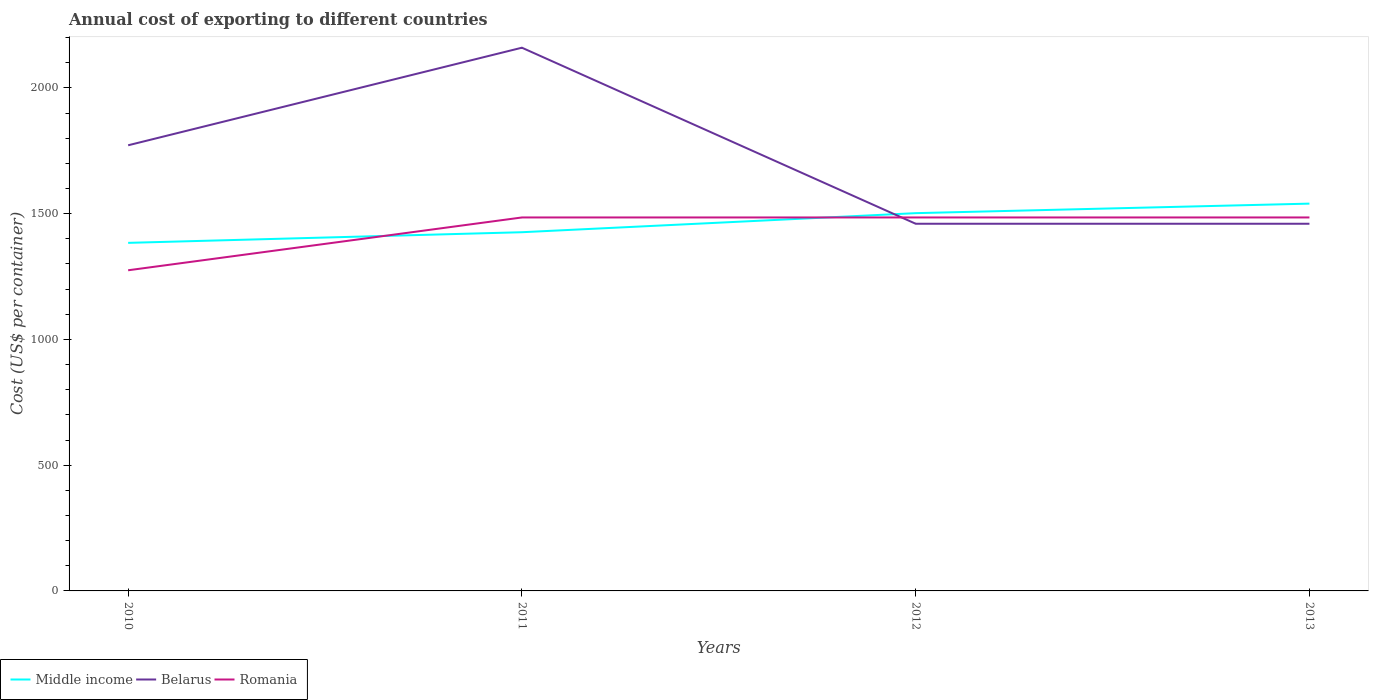Across all years, what is the maximum total annual cost of exporting in Middle income?
Provide a short and direct response. 1383.99. In which year was the total annual cost of exporting in Middle income maximum?
Provide a succinct answer. 2010. What is the total total annual cost of exporting in Middle income in the graph?
Offer a very short reply. -118.11. What is the difference between the highest and the second highest total annual cost of exporting in Middle income?
Your answer should be compact. 156.01. Is the total annual cost of exporting in Romania strictly greater than the total annual cost of exporting in Belarus over the years?
Keep it short and to the point. No. How many years are there in the graph?
Your response must be concise. 4. Where does the legend appear in the graph?
Your answer should be compact. Bottom left. How are the legend labels stacked?
Make the answer very short. Horizontal. What is the title of the graph?
Make the answer very short. Annual cost of exporting to different countries. Does "OECD members" appear as one of the legend labels in the graph?
Provide a succinct answer. No. What is the label or title of the X-axis?
Your answer should be very brief. Years. What is the label or title of the Y-axis?
Your answer should be compact. Cost (US$ per container). What is the Cost (US$ per container) of Middle income in 2010?
Keep it short and to the point. 1383.99. What is the Cost (US$ per container) in Belarus in 2010?
Your response must be concise. 1772. What is the Cost (US$ per container) in Romania in 2010?
Provide a short and direct response. 1275. What is the Cost (US$ per container) of Middle income in 2011?
Ensure brevity in your answer.  1426.34. What is the Cost (US$ per container) of Belarus in 2011?
Your answer should be compact. 2160. What is the Cost (US$ per container) in Romania in 2011?
Ensure brevity in your answer.  1485. What is the Cost (US$ per container) of Middle income in 2012?
Your response must be concise. 1502.1. What is the Cost (US$ per container) in Belarus in 2012?
Keep it short and to the point. 1460. What is the Cost (US$ per container) in Romania in 2012?
Give a very brief answer. 1485. What is the Cost (US$ per container) of Middle income in 2013?
Offer a terse response. 1540. What is the Cost (US$ per container) of Belarus in 2013?
Provide a short and direct response. 1460. What is the Cost (US$ per container) of Romania in 2013?
Provide a short and direct response. 1485. Across all years, what is the maximum Cost (US$ per container) of Middle income?
Your response must be concise. 1540. Across all years, what is the maximum Cost (US$ per container) of Belarus?
Make the answer very short. 2160. Across all years, what is the maximum Cost (US$ per container) in Romania?
Give a very brief answer. 1485. Across all years, what is the minimum Cost (US$ per container) of Middle income?
Provide a short and direct response. 1383.99. Across all years, what is the minimum Cost (US$ per container) of Belarus?
Your answer should be compact. 1460. Across all years, what is the minimum Cost (US$ per container) in Romania?
Provide a short and direct response. 1275. What is the total Cost (US$ per container) of Middle income in the graph?
Provide a succinct answer. 5852.42. What is the total Cost (US$ per container) in Belarus in the graph?
Make the answer very short. 6852. What is the total Cost (US$ per container) in Romania in the graph?
Give a very brief answer. 5730. What is the difference between the Cost (US$ per container) of Middle income in 2010 and that in 2011?
Your answer should be compact. -42.35. What is the difference between the Cost (US$ per container) in Belarus in 2010 and that in 2011?
Your answer should be very brief. -388. What is the difference between the Cost (US$ per container) of Romania in 2010 and that in 2011?
Provide a succinct answer. -210. What is the difference between the Cost (US$ per container) in Middle income in 2010 and that in 2012?
Provide a succinct answer. -118.11. What is the difference between the Cost (US$ per container) of Belarus in 2010 and that in 2012?
Keep it short and to the point. 312. What is the difference between the Cost (US$ per container) in Romania in 2010 and that in 2012?
Your answer should be very brief. -210. What is the difference between the Cost (US$ per container) of Middle income in 2010 and that in 2013?
Give a very brief answer. -156.01. What is the difference between the Cost (US$ per container) in Belarus in 2010 and that in 2013?
Your answer should be very brief. 312. What is the difference between the Cost (US$ per container) of Romania in 2010 and that in 2013?
Offer a very short reply. -210. What is the difference between the Cost (US$ per container) of Middle income in 2011 and that in 2012?
Offer a terse response. -75.76. What is the difference between the Cost (US$ per container) of Belarus in 2011 and that in 2012?
Give a very brief answer. 700. What is the difference between the Cost (US$ per container) of Romania in 2011 and that in 2012?
Give a very brief answer. 0. What is the difference between the Cost (US$ per container) in Middle income in 2011 and that in 2013?
Your response must be concise. -113.66. What is the difference between the Cost (US$ per container) of Belarus in 2011 and that in 2013?
Make the answer very short. 700. What is the difference between the Cost (US$ per container) in Romania in 2011 and that in 2013?
Your answer should be compact. 0. What is the difference between the Cost (US$ per container) in Middle income in 2012 and that in 2013?
Keep it short and to the point. -37.9. What is the difference between the Cost (US$ per container) of Romania in 2012 and that in 2013?
Your answer should be very brief. 0. What is the difference between the Cost (US$ per container) of Middle income in 2010 and the Cost (US$ per container) of Belarus in 2011?
Give a very brief answer. -776.01. What is the difference between the Cost (US$ per container) of Middle income in 2010 and the Cost (US$ per container) of Romania in 2011?
Your answer should be very brief. -101.01. What is the difference between the Cost (US$ per container) in Belarus in 2010 and the Cost (US$ per container) in Romania in 2011?
Provide a short and direct response. 287. What is the difference between the Cost (US$ per container) of Middle income in 2010 and the Cost (US$ per container) of Belarus in 2012?
Provide a succinct answer. -76.01. What is the difference between the Cost (US$ per container) in Middle income in 2010 and the Cost (US$ per container) in Romania in 2012?
Your response must be concise. -101.01. What is the difference between the Cost (US$ per container) in Belarus in 2010 and the Cost (US$ per container) in Romania in 2012?
Provide a succinct answer. 287. What is the difference between the Cost (US$ per container) of Middle income in 2010 and the Cost (US$ per container) of Belarus in 2013?
Provide a short and direct response. -76.01. What is the difference between the Cost (US$ per container) of Middle income in 2010 and the Cost (US$ per container) of Romania in 2013?
Give a very brief answer. -101.01. What is the difference between the Cost (US$ per container) of Belarus in 2010 and the Cost (US$ per container) of Romania in 2013?
Your answer should be very brief. 287. What is the difference between the Cost (US$ per container) of Middle income in 2011 and the Cost (US$ per container) of Belarus in 2012?
Your answer should be very brief. -33.66. What is the difference between the Cost (US$ per container) in Middle income in 2011 and the Cost (US$ per container) in Romania in 2012?
Offer a terse response. -58.66. What is the difference between the Cost (US$ per container) in Belarus in 2011 and the Cost (US$ per container) in Romania in 2012?
Your answer should be compact. 675. What is the difference between the Cost (US$ per container) in Middle income in 2011 and the Cost (US$ per container) in Belarus in 2013?
Your answer should be compact. -33.66. What is the difference between the Cost (US$ per container) in Middle income in 2011 and the Cost (US$ per container) in Romania in 2013?
Keep it short and to the point. -58.66. What is the difference between the Cost (US$ per container) of Belarus in 2011 and the Cost (US$ per container) of Romania in 2013?
Your answer should be very brief. 675. What is the difference between the Cost (US$ per container) in Middle income in 2012 and the Cost (US$ per container) in Belarus in 2013?
Provide a short and direct response. 42.1. What is the difference between the Cost (US$ per container) of Belarus in 2012 and the Cost (US$ per container) of Romania in 2013?
Ensure brevity in your answer.  -25. What is the average Cost (US$ per container) in Middle income per year?
Provide a short and direct response. 1463.11. What is the average Cost (US$ per container) of Belarus per year?
Give a very brief answer. 1713. What is the average Cost (US$ per container) in Romania per year?
Keep it short and to the point. 1432.5. In the year 2010, what is the difference between the Cost (US$ per container) in Middle income and Cost (US$ per container) in Belarus?
Provide a succinct answer. -388.01. In the year 2010, what is the difference between the Cost (US$ per container) in Middle income and Cost (US$ per container) in Romania?
Your answer should be very brief. 108.99. In the year 2010, what is the difference between the Cost (US$ per container) in Belarus and Cost (US$ per container) in Romania?
Keep it short and to the point. 497. In the year 2011, what is the difference between the Cost (US$ per container) of Middle income and Cost (US$ per container) of Belarus?
Your response must be concise. -733.66. In the year 2011, what is the difference between the Cost (US$ per container) in Middle income and Cost (US$ per container) in Romania?
Make the answer very short. -58.66. In the year 2011, what is the difference between the Cost (US$ per container) of Belarus and Cost (US$ per container) of Romania?
Offer a terse response. 675. In the year 2012, what is the difference between the Cost (US$ per container) in Middle income and Cost (US$ per container) in Belarus?
Provide a succinct answer. 42.1. In the year 2012, what is the difference between the Cost (US$ per container) of Middle income and Cost (US$ per container) of Romania?
Make the answer very short. 17.1. In the year 2012, what is the difference between the Cost (US$ per container) in Belarus and Cost (US$ per container) in Romania?
Your response must be concise. -25. In the year 2013, what is the difference between the Cost (US$ per container) of Middle income and Cost (US$ per container) of Belarus?
Your answer should be compact. 80. In the year 2013, what is the difference between the Cost (US$ per container) in Middle income and Cost (US$ per container) in Romania?
Your response must be concise. 55. In the year 2013, what is the difference between the Cost (US$ per container) in Belarus and Cost (US$ per container) in Romania?
Ensure brevity in your answer.  -25. What is the ratio of the Cost (US$ per container) in Middle income in 2010 to that in 2011?
Provide a short and direct response. 0.97. What is the ratio of the Cost (US$ per container) in Belarus in 2010 to that in 2011?
Offer a terse response. 0.82. What is the ratio of the Cost (US$ per container) in Romania in 2010 to that in 2011?
Ensure brevity in your answer.  0.86. What is the ratio of the Cost (US$ per container) in Middle income in 2010 to that in 2012?
Offer a very short reply. 0.92. What is the ratio of the Cost (US$ per container) of Belarus in 2010 to that in 2012?
Make the answer very short. 1.21. What is the ratio of the Cost (US$ per container) in Romania in 2010 to that in 2012?
Keep it short and to the point. 0.86. What is the ratio of the Cost (US$ per container) of Middle income in 2010 to that in 2013?
Your answer should be very brief. 0.9. What is the ratio of the Cost (US$ per container) of Belarus in 2010 to that in 2013?
Offer a very short reply. 1.21. What is the ratio of the Cost (US$ per container) of Romania in 2010 to that in 2013?
Keep it short and to the point. 0.86. What is the ratio of the Cost (US$ per container) in Middle income in 2011 to that in 2012?
Make the answer very short. 0.95. What is the ratio of the Cost (US$ per container) in Belarus in 2011 to that in 2012?
Make the answer very short. 1.48. What is the ratio of the Cost (US$ per container) in Romania in 2011 to that in 2012?
Keep it short and to the point. 1. What is the ratio of the Cost (US$ per container) in Middle income in 2011 to that in 2013?
Offer a very short reply. 0.93. What is the ratio of the Cost (US$ per container) of Belarus in 2011 to that in 2013?
Keep it short and to the point. 1.48. What is the ratio of the Cost (US$ per container) in Middle income in 2012 to that in 2013?
Keep it short and to the point. 0.98. What is the ratio of the Cost (US$ per container) of Romania in 2012 to that in 2013?
Provide a short and direct response. 1. What is the difference between the highest and the second highest Cost (US$ per container) in Middle income?
Provide a short and direct response. 37.9. What is the difference between the highest and the second highest Cost (US$ per container) of Belarus?
Provide a short and direct response. 388. What is the difference between the highest and the second highest Cost (US$ per container) in Romania?
Provide a short and direct response. 0. What is the difference between the highest and the lowest Cost (US$ per container) of Middle income?
Offer a very short reply. 156.01. What is the difference between the highest and the lowest Cost (US$ per container) in Belarus?
Provide a succinct answer. 700. What is the difference between the highest and the lowest Cost (US$ per container) in Romania?
Your response must be concise. 210. 